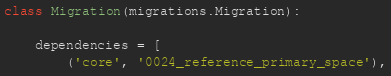Convert code to text. <code><loc_0><loc_0><loc_500><loc_500><_Python_>class Migration(migrations.Migration):

    dependencies = [
        ('core', '0024_reference_primary_space'),</code> 